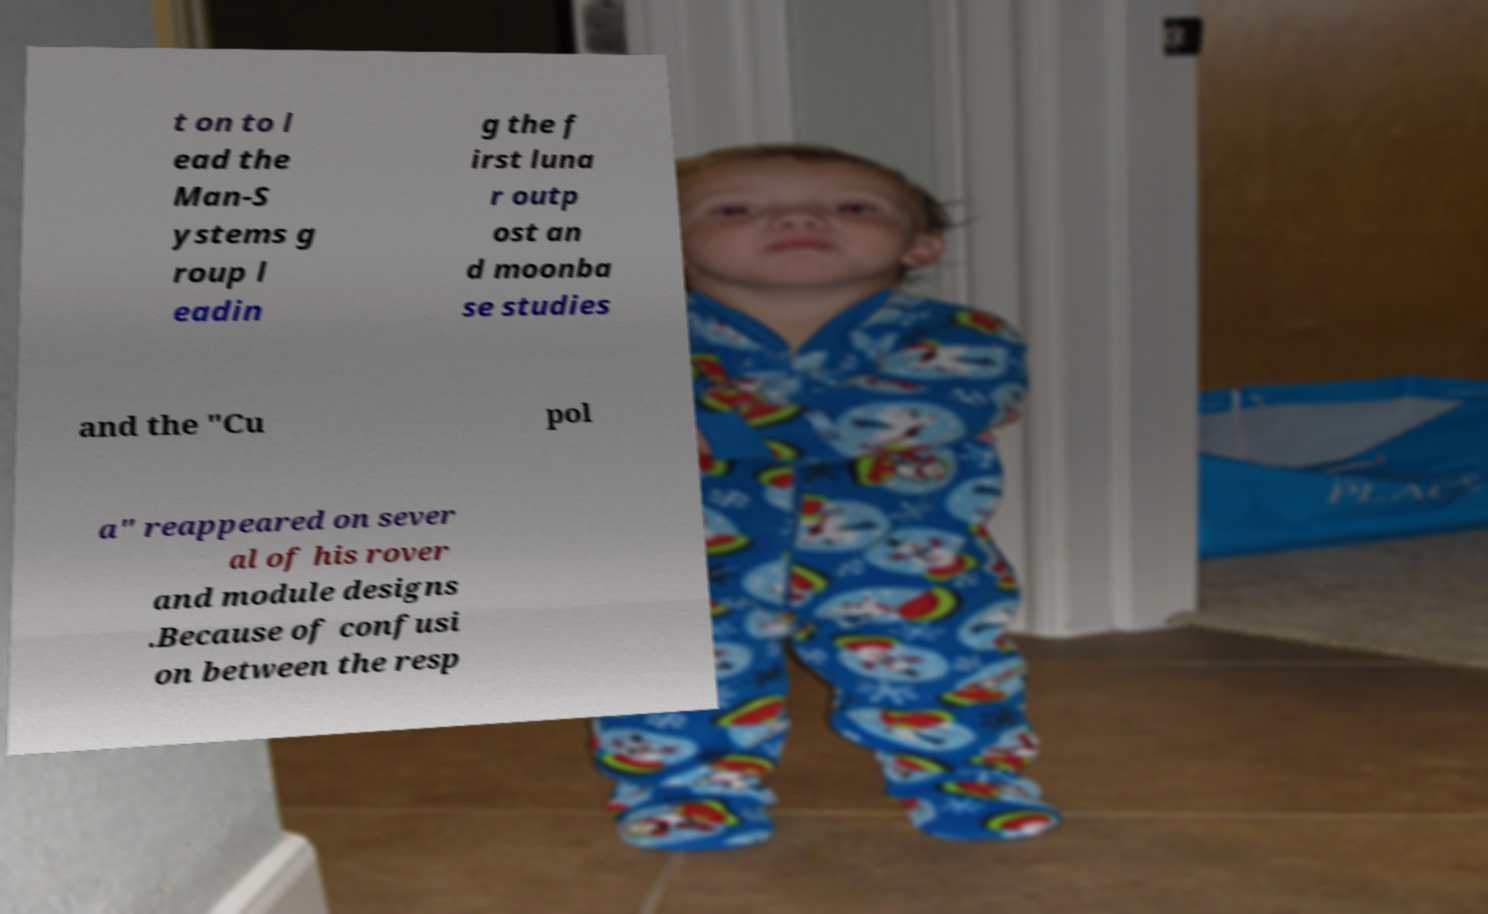For documentation purposes, I need the text within this image transcribed. Could you provide that? t on to l ead the Man-S ystems g roup l eadin g the f irst luna r outp ost an d moonba se studies and the "Cu pol a" reappeared on sever al of his rover and module designs .Because of confusi on between the resp 